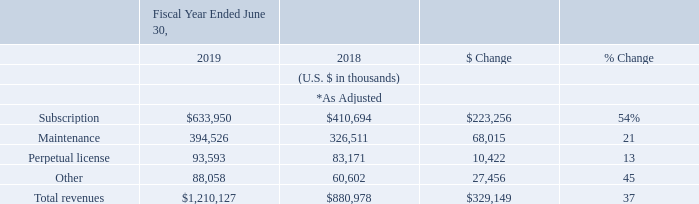Fiscal Year Ended 2019 and 2018 Revenues
* Adjusted IFRS balances to reflect the impact of the full retrospective adoption of IFRS 15. See Note 2 of the notes to our consolidated financial statements for further details.
Total revenues increased $329.1 million, or 37%, in the fiscal year ended June 30, 2019 compared to the fiscal year ended June 30, 2018. Growth in total revenues was attributable to increased demand for our products from both new and existing customers. Of total revenues recognized in the fiscal year ended June 30, 2019, over 90% was attributable to sales to customer accounts existing on or before June 30, 2018. Our number of total customers increased to 152,727 at June 30, 2019 from 125,796 at June 30, 2018.
Subscription revenues increased $223.3 million, or 54%, in the fiscal year ended June 30, 2019 compared to the fiscal year ended June 30, 2018. The increase in subscription revenues was primarily attributable to additional subscriptions from our existing customer base. As customers increasingly adopt cloud-based, subscription services and term-based licenses of our Data Center products for their business needs, we expect our subscription revenues to continue to increase at a rate higher than the rate of increase of our perpetual license revenues in future periods.
Maintenance revenues increased $68.0 million, or 21%, in the fiscal year ended June 30, 2019 compared to the fiscal year ended June 30, 2018. The increase in maintenance revenues was primarily attributable to growing renewal of software maintenance contracts from our customers related to our perpetual license software offerings.
Perpetual license revenues increased $10.4 million, or 13%, in the fiscal year ended June 30, 2019 compared to the fiscal year ended June 30, 2018. A substantial majority of the increase in perpetual license revenues was attributable to additional licenses to existing customers.
Other revenues increased $27.5 million, or 45%, in the fiscal year ended June 30, 2019 compared to the fiscal year ended June 30, 2018. The increase in other revenues was primarily attributable to an increase in revenue from sales of third-party apps through our Atlassian Marketplace.
What was the increase of maintenance revenues from fiscal year ended 2018 to 2019? $68.0 million. What was the main reason for the increase in maintenance revenues? Growing renewal of software maintenance contracts from our customers related to our perpetual license software offerings. What was the increase of perpetual license revenues from fiscal year ended 2018 to 2019? $10.4 million. For fiscal year ended 2019, what is the difference in subscription revenue and maintenance revenue?
Answer scale should be: thousand. 633,950-394,526
Answer: 239424. For fiscal year ended 2018, what is the percentage constitution of perpetual license among the total revenue?
Answer scale should be: percent. 83,171/880,978
Answer: 9.44. What is the average maintenance revenues for fiscal year ended 2018 and 2019?
Answer scale should be: thousand. (394,526+326,511)/2
Answer: 360518.5. 